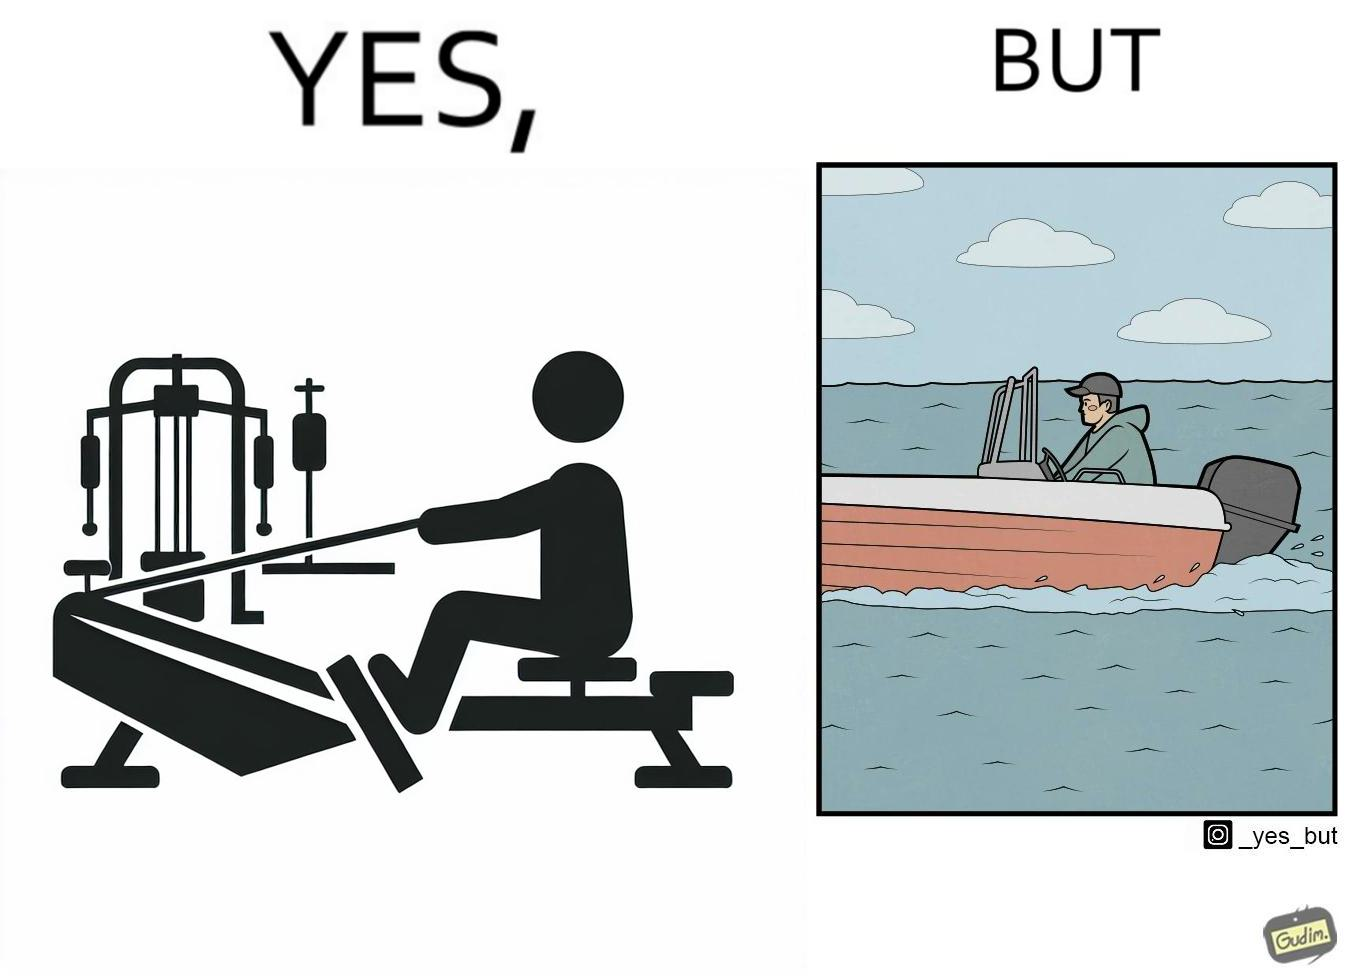Does this image contain satire or humor? Yes, this image is satirical. 